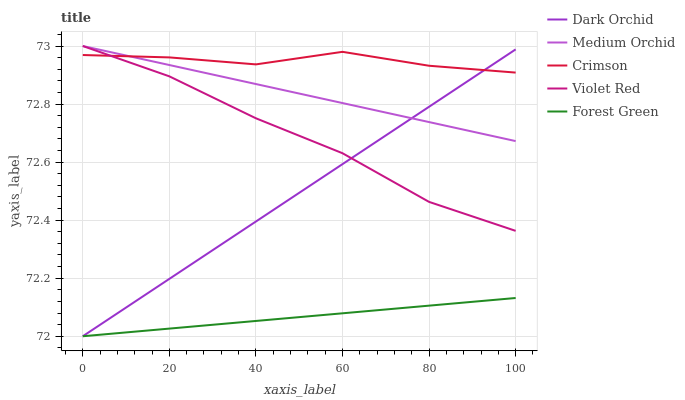Does Forest Green have the minimum area under the curve?
Answer yes or no. Yes. Does Crimson have the maximum area under the curve?
Answer yes or no. Yes. Does Violet Red have the minimum area under the curve?
Answer yes or no. No. Does Violet Red have the maximum area under the curve?
Answer yes or no. No. Is Dark Orchid the smoothest?
Answer yes or no. Yes. Is Crimson the roughest?
Answer yes or no. Yes. Is Violet Red the smoothest?
Answer yes or no. No. Is Violet Red the roughest?
Answer yes or no. No. Does Forest Green have the lowest value?
Answer yes or no. Yes. Does Violet Red have the lowest value?
Answer yes or no. No. Does Medium Orchid have the highest value?
Answer yes or no. Yes. Does Forest Green have the highest value?
Answer yes or no. No. Is Forest Green less than Medium Orchid?
Answer yes or no. Yes. Is Crimson greater than Forest Green?
Answer yes or no. Yes. Does Crimson intersect Violet Red?
Answer yes or no. Yes. Is Crimson less than Violet Red?
Answer yes or no. No. Is Crimson greater than Violet Red?
Answer yes or no. No. Does Forest Green intersect Medium Orchid?
Answer yes or no. No. 